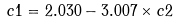Convert formula to latex. <formula><loc_0><loc_0><loc_500><loc_500>c 1 = 2 . 0 3 0 - 3 . 0 0 7 \times c 2 \\</formula> 